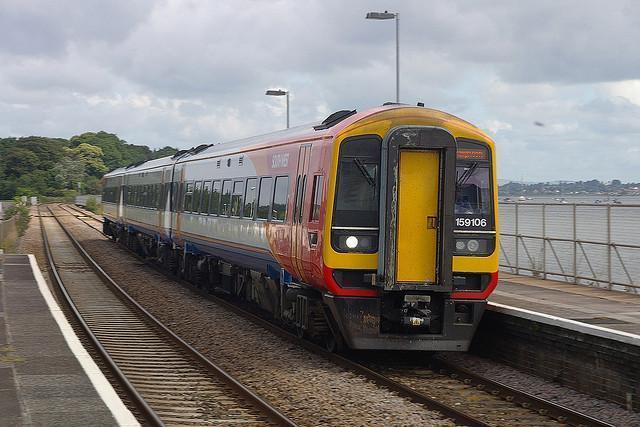How many trains?
Give a very brief answer. 1. 